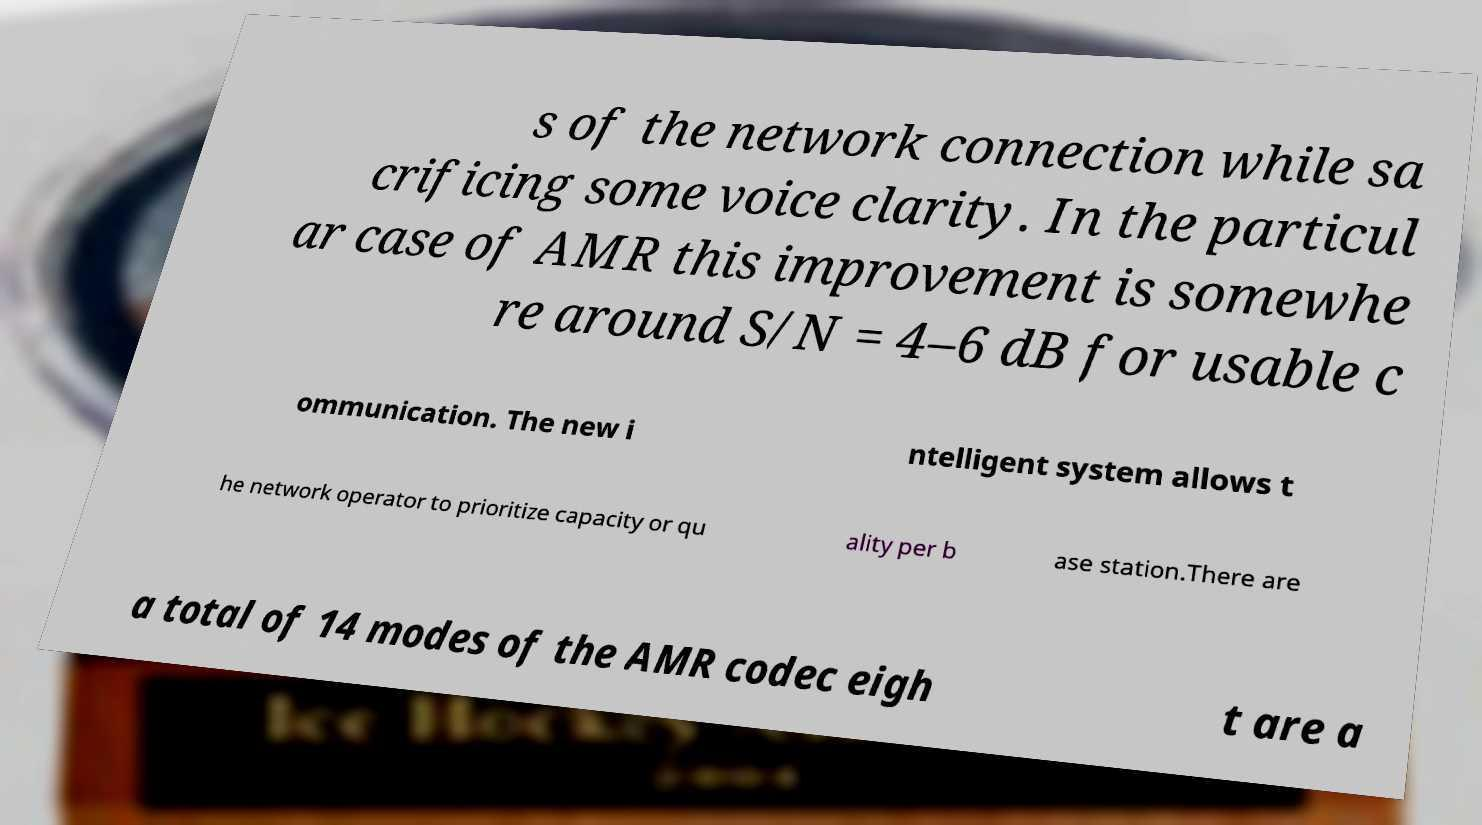Please identify and transcribe the text found in this image. s of the network connection while sa crificing some voice clarity. In the particul ar case of AMR this improvement is somewhe re around S/N = 4–6 dB for usable c ommunication. The new i ntelligent system allows t he network operator to prioritize capacity or qu ality per b ase station.There are a total of 14 modes of the AMR codec eigh t are a 